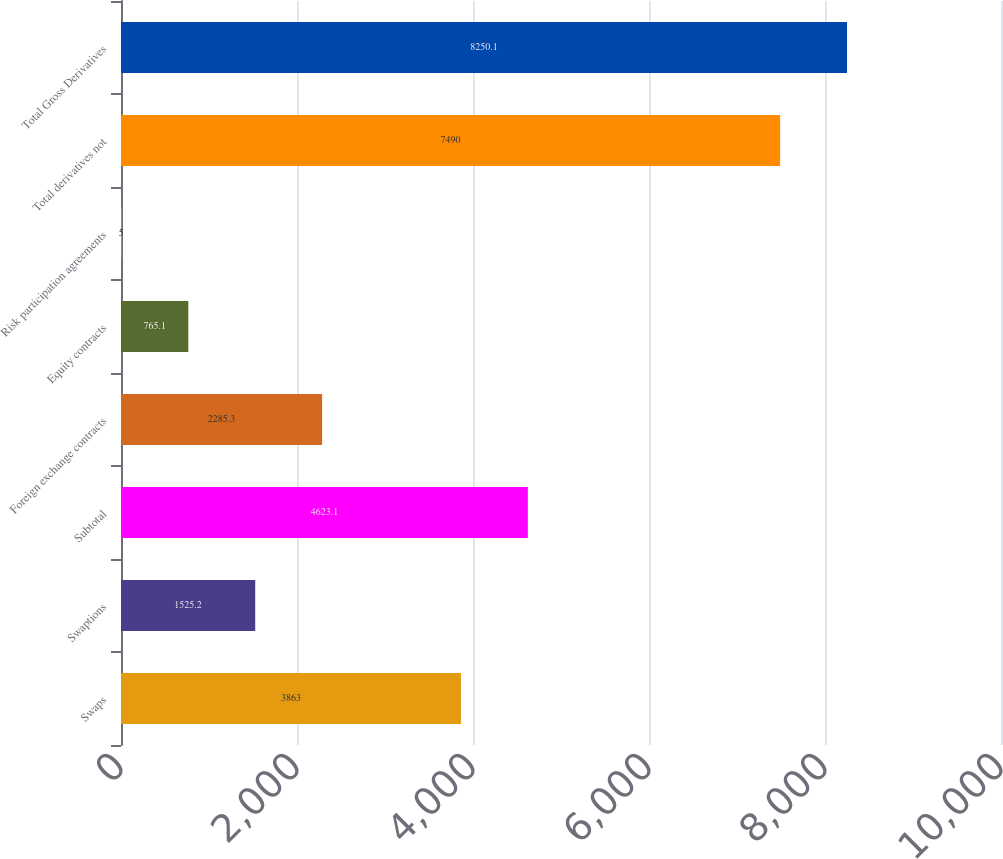<chart> <loc_0><loc_0><loc_500><loc_500><bar_chart><fcel>Swaps<fcel>Swaptions<fcel>Subtotal<fcel>Foreign exchange contracts<fcel>Equity contracts<fcel>Risk participation agreements<fcel>Total derivatives not<fcel>Total Gross Derivatives<nl><fcel>3863<fcel>1525.2<fcel>4623.1<fcel>2285.3<fcel>765.1<fcel>5<fcel>7490<fcel>8250.1<nl></chart> 